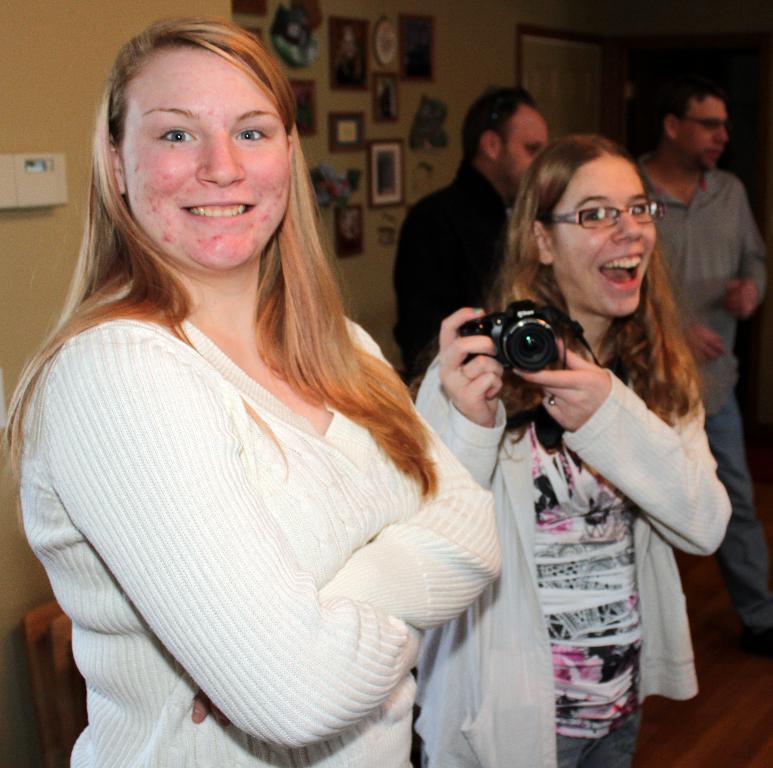How would you summarize this image in a sentence or two? In this image I see 2 girls who are smiling and one of them is holding a camera. In the background I see the wall and few things on it and 2 men over here. 